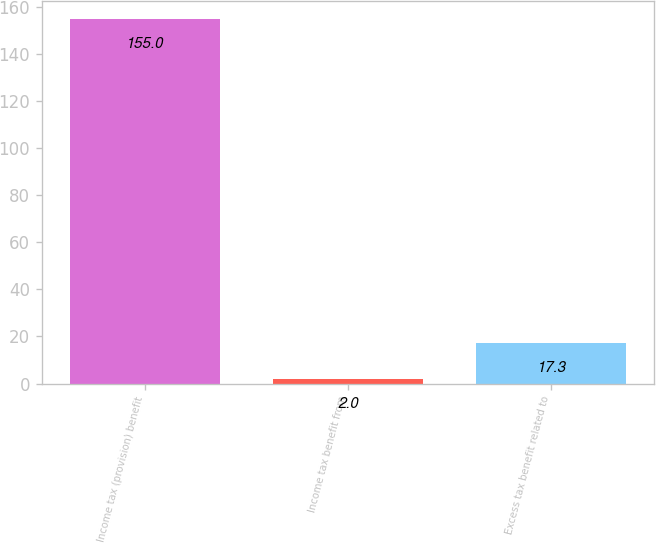<chart> <loc_0><loc_0><loc_500><loc_500><bar_chart><fcel>Income tax (provision) benefit<fcel>Income tax benefit from<fcel>Excess tax benefit related to<nl><fcel>155<fcel>2<fcel>17.3<nl></chart> 